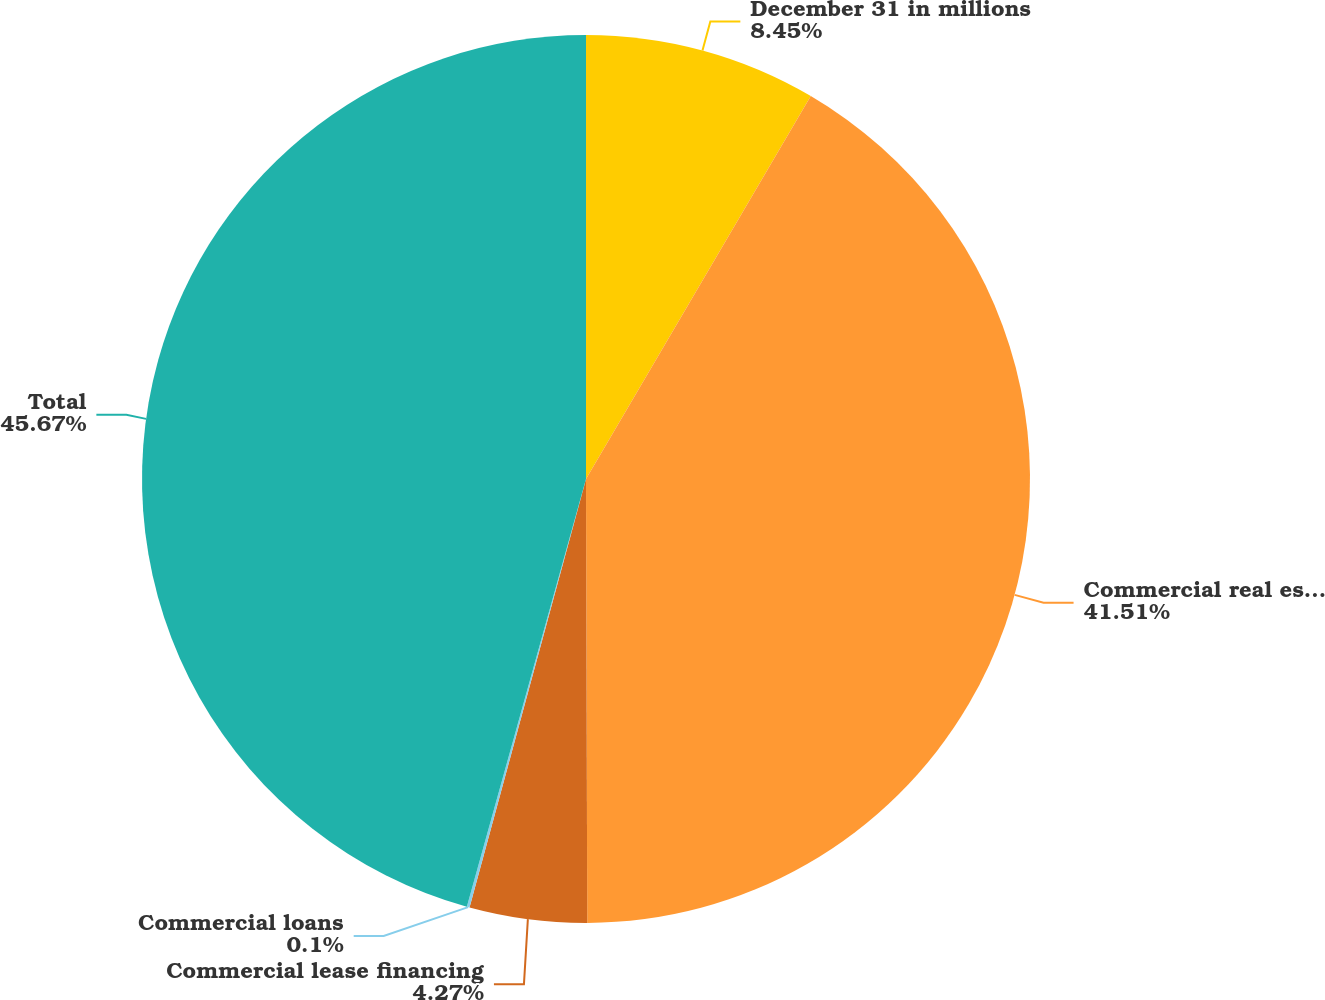Convert chart to OTSL. <chart><loc_0><loc_0><loc_500><loc_500><pie_chart><fcel>December 31 in millions<fcel>Commercial real estate loans<fcel>Commercial lease financing<fcel>Commercial loans<fcel>Total<nl><fcel>8.45%<fcel>41.51%<fcel>4.27%<fcel>0.1%<fcel>45.68%<nl></chart> 